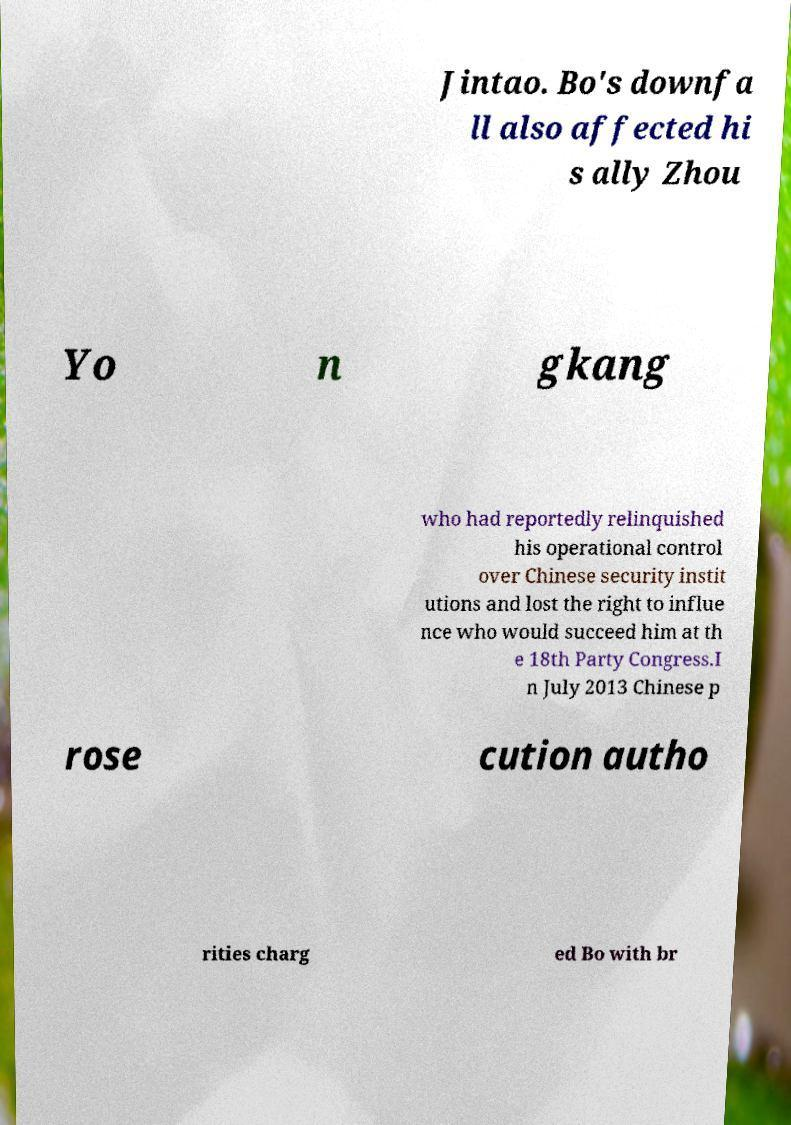What messages or text are displayed in this image? I need them in a readable, typed format. Jintao. Bo's downfa ll also affected hi s ally Zhou Yo n gkang who had reportedly relinquished his operational control over Chinese security instit utions and lost the right to influe nce who would succeed him at th e 18th Party Congress.I n July 2013 Chinese p rose cution autho rities charg ed Bo with br 